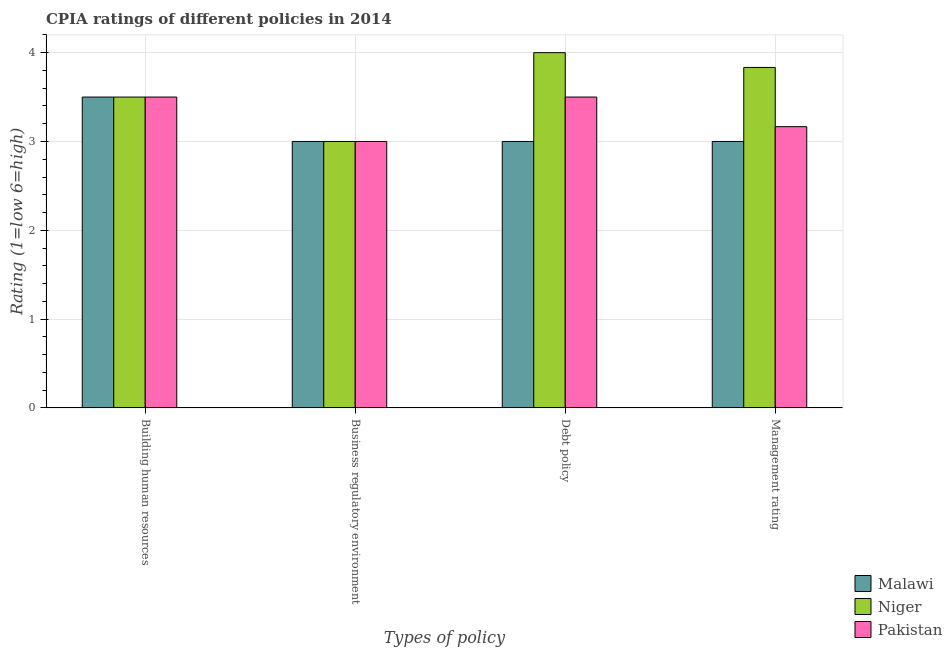What is the label of the 3rd group of bars from the left?
Keep it short and to the point. Debt policy. Across all countries, what is the maximum cpia rating of management?
Make the answer very short. 3.83. Across all countries, what is the minimum cpia rating of debt policy?
Ensure brevity in your answer.  3. In which country was the cpia rating of business regulatory environment maximum?
Your response must be concise. Malawi. In which country was the cpia rating of debt policy minimum?
Your response must be concise. Malawi. What is the total cpia rating of building human resources in the graph?
Make the answer very short. 10.5. What is the difference between the cpia rating of building human resources in Niger and that in Pakistan?
Your answer should be very brief. 0. What is the difference between the cpia rating of management in Pakistan and the cpia rating of building human resources in Niger?
Offer a very short reply. -0.33. What is the average cpia rating of building human resources per country?
Make the answer very short. 3.5. In how many countries, is the cpia rating of management greater than 2 ?
Offer a terse response. 3. What is the ratio of the cpia rating of debt policy in Niger to that in Malawi?
Give a very brief answer. 1.33. Is the cpia rating of business regulatory environment in Pakistan less than that in Niger?
Offer a very short reply. No. Is the difference between the cpia rating of business regulatory environment in Niger and Pakistan greater than the difference between the cpia rating of building human resources in Niger and Pakistan?
Your response must be concise. No. What is the difference between the highest and the second highest cpia rating of debt policy?
Provide a short and direct response. 0.5. What does the 1st bar from the left in Debt policy represents?
Provide a short and direct response. Malawi. What does the 3rd bar from the right in Debt policy represents?
Provide a succinct answer. Malawi. Is it the case that in every country, the sum of the cpia rating of building human resources and cpia rating of business regulatory environment is greater than the cpia rating of debt policy?
Your answer should be very brief. Yes. Are all the bars in the graph horizontal?
Keep it short and to the point. No. What is the difference between two consecutive major ticks on the Y-axis?
Provide a short and direct response. 1. Does the graph contain any zero values?
Offer a terse response. No. Does the graph contain grids?
Your answer should be very brief. Yes. How many legend labels are there?
Ensure brevity in your answer.  3. How are the legend labels stacked?
Provide a short and direct response. Vertical. What is the title of the graph?
Provide a short and direct response. CPIA ratings of different policies in 2014. What is the label or title of the X-axis?
Provide a succinct answer. Types of policy. What is the Rating (1=low 6=high) in Malawi in Debt policy?
Provide a succinct answer. 3. What is the Rating (1=low 6=high) of Niger in Debt policy?
Your answer should be compact. 4. What is the Rating (1=low 6=high) in Pakistan in Debt policy?
Your answer should be compact. 3.5. What is the Rating (1=low 6=high) of Niger in Management rating?
Provide a succinct answer. 3.83. What is the Rating (1=low 6=high) in Pakistan in Management rating?
Make the answer very short. 3.17. Across all Types of policy, what is the maximum Rating (1=low 6=high) in Pakistan?
Provide a succinct answer. 3.5. Across all Types of policy, what is the minimum Rating (1=low 6=high) of Malawi?
Your response must be concise. 3. Across all Types of policy, what is the minimum Rating (1=low 6=high) in Niger?
Keep it short and to the point. 3. What is the total Rating (1=low 6=high) of Malawi in the graph?
Provide a succinct answer. 12.5. What is the total Rating (1=low 6=high) of Niger in the graph?
Offer a terse response. 14.33. What is the total Rating (1=low 6=high) in Pakistan in the graph?
Make the answer very short. 13.17. What is the difference between the Rating (1=low 6=high) of Niger in Building human resources and that in Business regulatory environment?
Provide a short and direct response. 0.5. What is the difference between the Rating (1=low 6=high) of Pakistan in Building human resources and that in Business regulatory environment?
Your answer should be very brief. 0.5. What is the difference between the Rating (1=low 6=high) in Niger in Building human resources and that in Debt policy?
Make the answer very short. -0.5. What is the difference between the Rating (1=low 6=high) in Pakistan in Building human resources and that in Debt policy?
Give a very brief answer. 0. What is the difference between the Rating (1=low 6=high) of Niger in Building human resources and that in Management rating?
Keep it short and to the point. -0.33. What is the difference between the Rating (1=low 6=high) of Malawi in Business regulatory environment and that in Debt policy?
Your response must be concise. 0. What is the difference between the Rating (1=low 6=high) of Malawi in Business regulatory environment and that in Management rating?
Ensure brevity in your answer.  0. What is the difference between the Rating (1=low 6=high) of Pakistan in Business regulatory environment and that in Management rating?
Make the answer very short. -0.17. What is the difference between the Rating (1=low 6=high) of Pakistan in Debt policy and that in Management rating?
Offer a terse response. 0.33. What is the difference between the Rating (1=low 6=high) of Malawi in Building human resources and the Rating (1=low 6=high) of Niger in Business regulatory environment?
Your answer should be very brief. 0.5. What is the difference between the Rating (1=low 6=high) of Malawi in Building human resources and the Rating (1=low 6=high) of Pakistan in Business regulatory environment?
Keep it short and to the point. 0.5. What is the difference between the Rating (1=low 6=high) of Malawi in Building human resources and the Rating (1=low 6=high) of Niger in Management rating?
Provide a succinct answer. -0.33. What is the difference between the Rating (1=low 6=high) in Malawi in Building human resources and the Rating (1=low 6=high) in Pakistan in Management rating?
Provide a succinct answer. 0.33. What is the difference between the Rating (1=low 6=high) of Niger in Building human resources and the Rating (1=low 6=high) of Pakistan in Management rating?
Ensure brevity in your answer.  0.33. What is the difference between the Rating (1=low 6=high) of Malawi in Business regulatory environment and the Rating (1=low 6=high) of Niger in Debt policy?
Offer a very short reply. -1. What is the difference between the Rating (1=low 6=high) in Malawi in Business regulatory environment and the Rating (1=low 6=high) in Pakistan in Debt policy?
Your response must be concise. -0.5. What is the difference between the Rating (1=low 6=high) of Niger in Business regulatory environment and the Rating (1=low 6=high) of Pakistan in Debt policy?
Offer a very short reply. -0.5. What is the difference between the Rating (1=low 6=high) in Malawi in Business regulatory environment and the Rating (1=low 6=high) in Pakistan in Management rating?
Your answer should be compact. -0.17. What is the difference between the Rating (1=low 6=high) in Niger in Business regulatory environment and the Rating (1=low 6=high) in Pakistan in Management rating?
Provide a succinct answer. -0.17. What is the difference between the Rating (1=low 6=high) in Malawi in Debt policy and the Rating (1=low 6=high) in Pakistan in Management rating?
Give a very brief answer. -0.17. What is the average Rating (1=low 6=high) in Malawi per Types of policy?
Keep it short and to the point. 3.12. What is the average Rating (1=low 6=high) in Niger per Types of policy?
Provide a succinct answer. 3.58. What is the average Rating (1=low 6=high) in Pakistan per Types of policy?
Offer a very short reply. 3.29. What is the difference between the Rating (1=low 6=high) in Malawi and Rating (1=low 6=high) in Niger in Building human resources?
Your answer should be compact. 0. What is the difference between the Rating (1=low 6=high) of Malawi and Rating (1=low 6=high) of Pakistan in Building human resources?
Ensure brevity in your answer.  0. What is the difference between the Rating (1=low 6=high) of Niger and Rating (1=low 6=high) of Pakistan in Building human resources?
Offer a very short reply. 0. What is the difference between the Rating (1=low 6=high) in Malawi and Rating (1=low 6=high) in Niger in Debt policy?
Ensure brevity in your answer.  -1. What is the difference between the Rating (1=low 6=high) in Malawi and Rating (1=low 6=high) in Pakistan in Debt policy?
Keep it short and to the point. -0.5. What is the difference between the Rating (1=low 6=high) in Malawi and Rating (1=low 6=high) in Niger in Management rating?
Provide a short and direct response. -0.83. What is the difference between the Rating (1=low 6=high) in Niger and Rating (1=low 6=high) in Pakistan in Management rating?
Provide a short and direct response. 0.67. What is the ratio of the Rating (1=low 6=high) of Malawi in Building human resources to that in Business regulatory environment?
Keep it short and to the point. 1.17. What is the ratio of the Rating (1=low 6=high) of Niger in Building human resources to that in Debt policy?
Make the answer very short. 0.88. What is the ratio of the Rating (1=low 6=high) of Niger in Building human resources to that in Management rating?
Offer a very short reply. 0.91. What is the ratio of the Rating (1=low 6=high) in Pakistan in Building human resources to that in Management rating?
Make the answer very short. 1.11. What is the ratio of the Rating (1=low 6=high) of Malawi in Business regulatory environment to that in Debt policy?
Give a very brief answer. 1. What is the ratio of the Rating (1=low 6=high) in Pakistan in Business regulatory environment to that in Debt policy?
Your answer should be compact. 0.86. What is the ratio of the Rating (1=low 6=high) in Malawi in Business regulatory environment to that in Management rating?
Ensure brevity in your answer.  1. What is the ratio of the Rating (1=low 6=high) of Niger in Business regulatory environment to that in Management rating?
Your answer should be very brief. 0.78. What is the ratio of the Rating (1=low 6=high) in Malawi in Debt policy to that in Management rating?
Ensure brevity in your answer.  1. What is the ratio of the Rating (1=low 6=high) of Niger in Debt policy to that in Management rating?
Your answer should be very brief. 1.04. What is the ratio of the Rating (1=low 6=high) of Pakistan in Debt policy to that in Management rating?
Your answer should be very brief. 1.11. What is the difference between the highest and the second highest Rating (1=low 6=high) of Malawi?
Keep it short and to the point. 0.5. What is the difference between the highest and the second highest Rating (1=low 6=high) of Niger?
Your response must be concise. 0.17. 